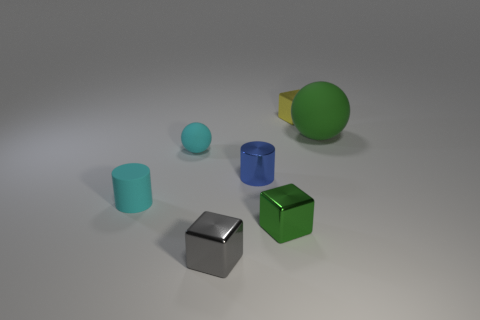Is the gray block made of the same material as the green cube?
Your answer should be very brief. Yes. There is a tiny thing that is both on the right side of the small ball and behind the tiny metallic cylinder; what is its color?
Offer a very short reply. Yellow. How big is the shiny block behind the sphere that is left of the small gray shiny object?
Make the answer very short. Small. Is the large sphere the same color as the small shiny cylinder?
Your answer should be compact. No. How many cubes have the same color as the large object?
Ensure brevity in your answer.  1. There is a rubber ball right of the green object on the left side of the yellow metallic block; is there a large matte object left of it?
Ensure brevity in your answer.  No. What is the shape of the green thing that is the same size as the blue object?
Your answer should be very brief. Cube. What is the color of the tiny cylinder that is made of the same material as the big thing?
Provide a succinct answer. Cyan. There is a big matte thing that is right of the tiny gray object; is it the same shape as the small object that is right of the small green metallic object?
Your answer should be compact. No. There is a tiny cylinder that is the same color as the small matte sphere; what is it made of?
Make the answer very short. Rubber. 